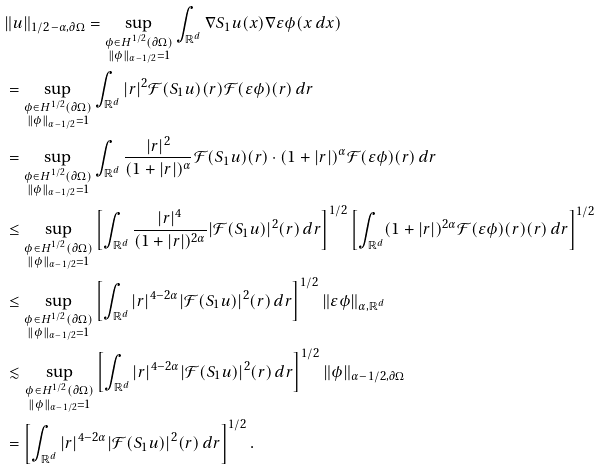<formula> <loc_0><loc_0><loc_500><loc_500>& \| u \| _ { 1 / 2 - \alpha , \partial \Omega } = \sup _ { \substack { \phi \in H ^ { 1 / 2 } ( \partial \Omega ) \\ \| \phi \| _ { \alpha - 1 / 2 } = 1 } } \int _ { \mathbb { R } ^ { d } } \nabla S _ { 1 } u ( x ) \nabla \varepsilon \phi ( x \, d x ) \\ & = \sup _ { \substack { \phi \in H ^ { 1 / 2 } ( \partial \Omega ) \\ \| \phi \| _ { \alpha - 1 / 2 } = 1 } } \int _ { \mathbb { R } ^ { d } } | r | ^ { 2 } \mathcal { F } ( S _ { 1 } u ) ( r ) \mathcal { F } ( \varepsilon \phi ) ( r ) \, d r \\ & = \sup _ { \substack { \phi \in H ^ { 1 / 2 } ( \partial \Omega ) \\ \| \phi \| _ { \alpha - 1 / 2 } = 1 } } \int _ { \mathbb { R } ^ { d } } \frac { | r | ^ { 2 } } { ( 1 + | r | ) ^ { \alpha } } \mathcal { F } ( S _ { 1 } u ) ( r ) \cdot ( 1 + | r | ) ^ { \alpha } \mathcal { F } ( \varepsilon \phi ) ( r ) \, d r \\ & \leq \sup _ { \substack { \phi \in H ^ { 1 / 2 } ( \partial \Omega ) \\ \| \phi \| _ { \alpha - 1 / 2 } = 1 } } \left [ \int _ { \mathbb { R } ^ { d } } \frac { | r | ^ { 4 } } { ( 1 + | r | ) ^ { 2 \alpha } } | \mathcal { F } ( S _ { 1 } u ) | ^ { 2 } ( r ) \, d r \right ] ^ { 1 / 2 } \left [ \int _ { \mathbb { R } ^ { d } } ( 1 + | r | ) ^ { 2 \alpha } \mathcal { F } ( \varepsilon \phi ) ( r ) ( r ) \, d r \right ] ^ { 1 / 2 } \\ & \leq \sup _ { \substack { \phi \in H ^ { 1 / 2 } ( \partial \Omega ) \\ \| \phi \| _ { \alpha - 1 / 2 } = 1 } } \left [ \int _ { \mathbb { R } ^ { d } } | r | ^ { 4 - 2 \alpha } | \mathcal { F } ( S _ { 1 } u ) | ^ { 2 } ( r ) \, d r \right ] ^ { 1 / 2 } \| \varepsilon \phi \| _ { \alpha , \mathbb { R } ^ { d } } \\ & \lesssim \sup _ { \substack { \phi \in H ^ { 1 / 2 } ( \partial \Omega ) \\ \| \phi \| _ { \alpha - 1 / 2 } = 1 } } \left [ \int _ { \mathbb { R } ^ { d } } | r | ^ { 4 - 2 \alpha } | \mathcal { F } ( S _ { 1 } u ) | ^ { 2 } ( r ) \, d r \right ] ^ { 1 / 2 } \| \phi \| _ { \alpha - 1 / 2 , \partial \Omega } \\ & = \left [ \int _ { \mathbb { R } ^ { d } } | r | ^ { 4 - 2 \alpha } | \mathcal { F } ( S _ { 1 } u ) | ^ { 2 } ( r ) \, d r \right ] ^ { 1 / 2 } .</formula> 